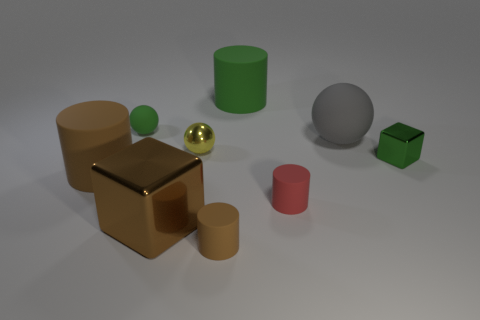Subtract 1 cylinders. How many cylinders are left? 3 Add 1 big matte spheres. How many objects exist? 10 Subtract all cubes. How many objects are left? 7 Add 3 brown cubes. How many brown cubes exist? 4 Subtract 0 red blocks. How many objects are left? 9 Subtract all brown metallic blocks. Subtract all brown cubes. How many objects are left? 7 Add 7 big cylinders. How many big cylinders are left? 9 